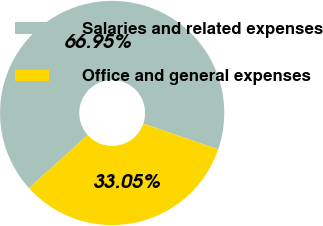Convert chart. <chart><loc_0><loc_0><loc_500><loc_500><pie_chart><fcel>Salaries and related expenses<fcel>Office and general expenses<nl><fcel>66.95%<fcel>33.05%<nl></chart> 